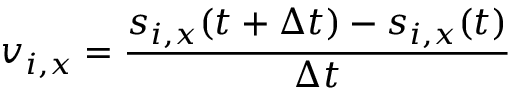<formula> <loc_0><loc_0><loc_500><loc_500>v _ { i , x } = \frac { s _ { i , x } ( t + \Delta t ) - s _ { i , x } ( t ) } { \Delta t }</formula> 